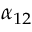<formula> <loc_0><loc_0><loc_500><loc_500>\alpha _ { 1 2 }</formula> 